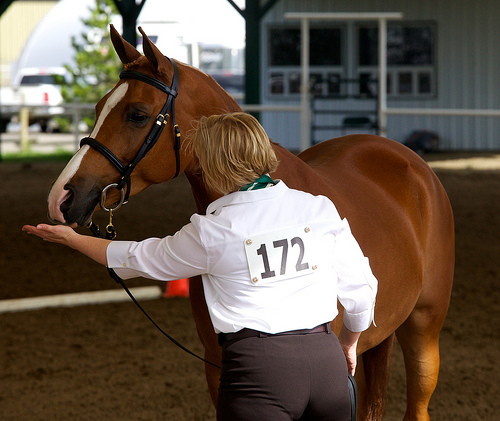<image>
Can you confirm if the jockey is on the horse? No. The jockey is not positioned on the horse. They may be near each other, but the jockey is not supported by or resting on top of the horse. 